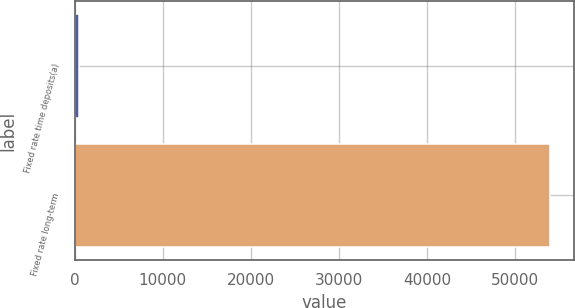Convert chart. <chart><loc_0><loc_0><loc_500><loc_500><bar_chart><fcel>Fixed rate time deposits(a)<fcel>Fixed rate long-term<nl><fcel>503<fcel>53983<nl></chart> 